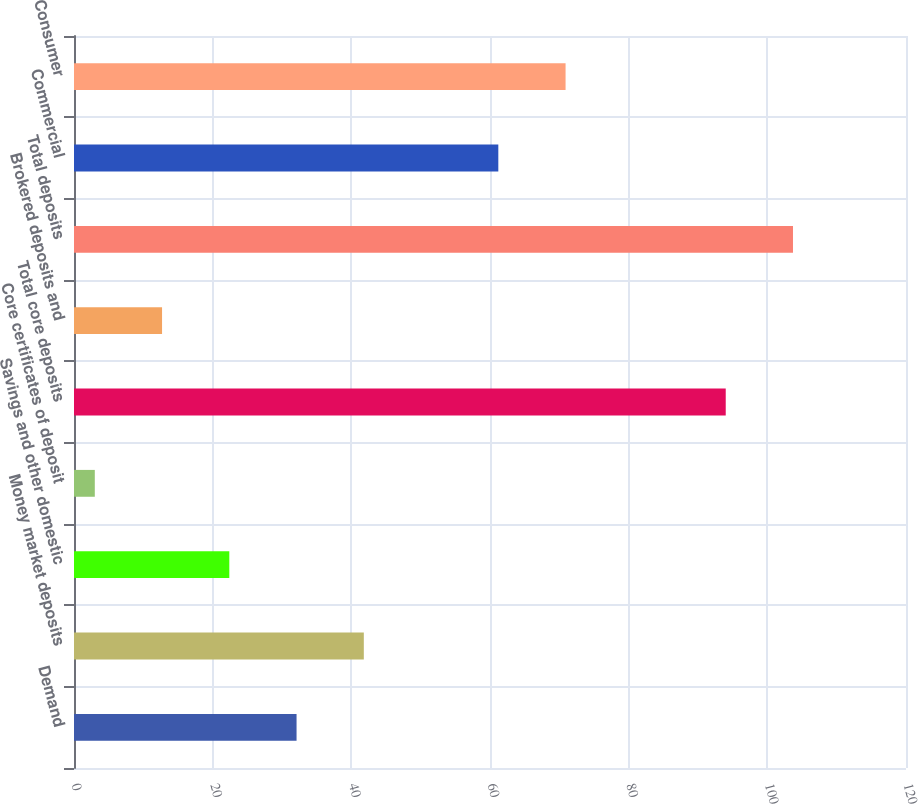Convert chart. <chart><loc_0><loc_0><loc_500><loc_500><bar_chart><fcel>Demand<fcel>Money market deposits<fcel>Savings and other domestic<fcel>Core certificates of deposit<fcel>Total core deposits<fcel>Brokered deposits and<fcel>Total deposits<fcel>Commercial<fcel>Consumer<nl><fcel>32.1<fcel>41.8<fcel>22.4<fcel>3<fcel>94<fcel>12.7<fcel>103.7<fcel>61.2<fcel>70.9<nl></chart> 